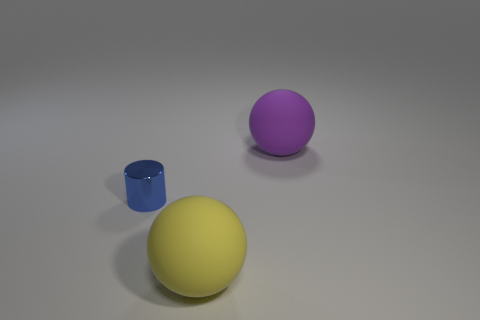The tiny blue metal object is what shape?
Provide a short and direct response. Cylinder. What number of yellow things have the same material as the blue cylinder?
Offer a terse response. 0. There is a sphere that is the same material as the large purple object; what is its color?
Provide a short and direct response. Yellow. There is a yellow rubber object; is it the same size as the ball right of the yellow sphere?
Your answer should be compact. Yes. The large thing that is in front of the big ball behind the metallic thing on the left side of the yellow ball is made of what material?
Give a very brief answer. Rubber. What number of things are big green metal cubes or rubber things?
Make the answer very short. 2. There is a object in front of the tiny shiny thing; is its color the same as the rubber thing that is behind the tiny cylinder?
Offer a very short reply. No. The purple matte object that is the same size as the yellow sphere is what shape?
Your response must be concise. Sphere. How many things are big rubber balls behind the yellow rubber sphere or objects on the left side of the purple ball?
Your answer should be very brief. 3. Is the number of large balls less than the number of objects?
Offer a terse response. Yes. 